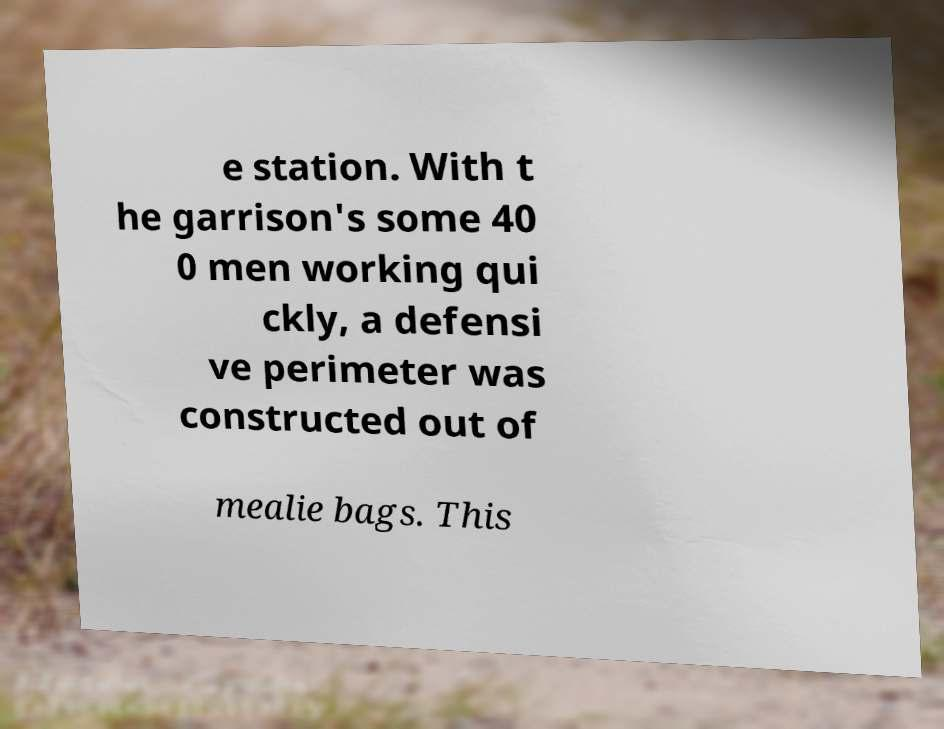Can you read and provide the text displayed in the image?This photo seems to have some interesting text. Can you extract and type it out for me? e station. With t he garrison's some 40 0 men working qui ckly, a defensi ve perimeter was constructed out of mealie bags. This 